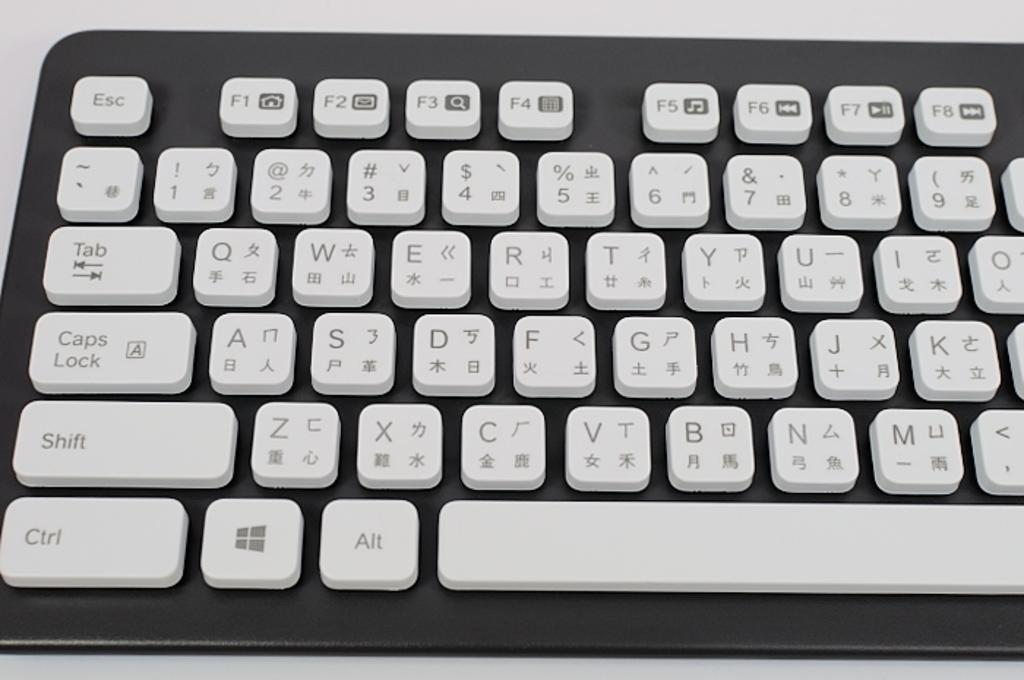Provide a one-sentence caption for the provided image. a chinese keyboard that has both chinese and english on it. 